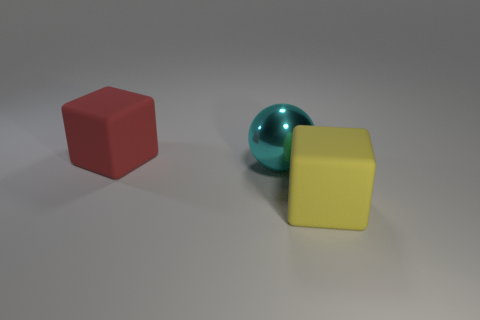Add 3 yellow matte things. How many objects exist? 6 Subtract all cubes. How many objects are left? 1 Add 3 yellow objects. How many yellow objects are left? 4 Add 2 red matte blocks. How many red matte blocks exist? 3 Subtract 0 blue cubes. How many objects are left? 3 Subtract all yellow cubes. Subtract all yellow things. How many objects are left? 1 